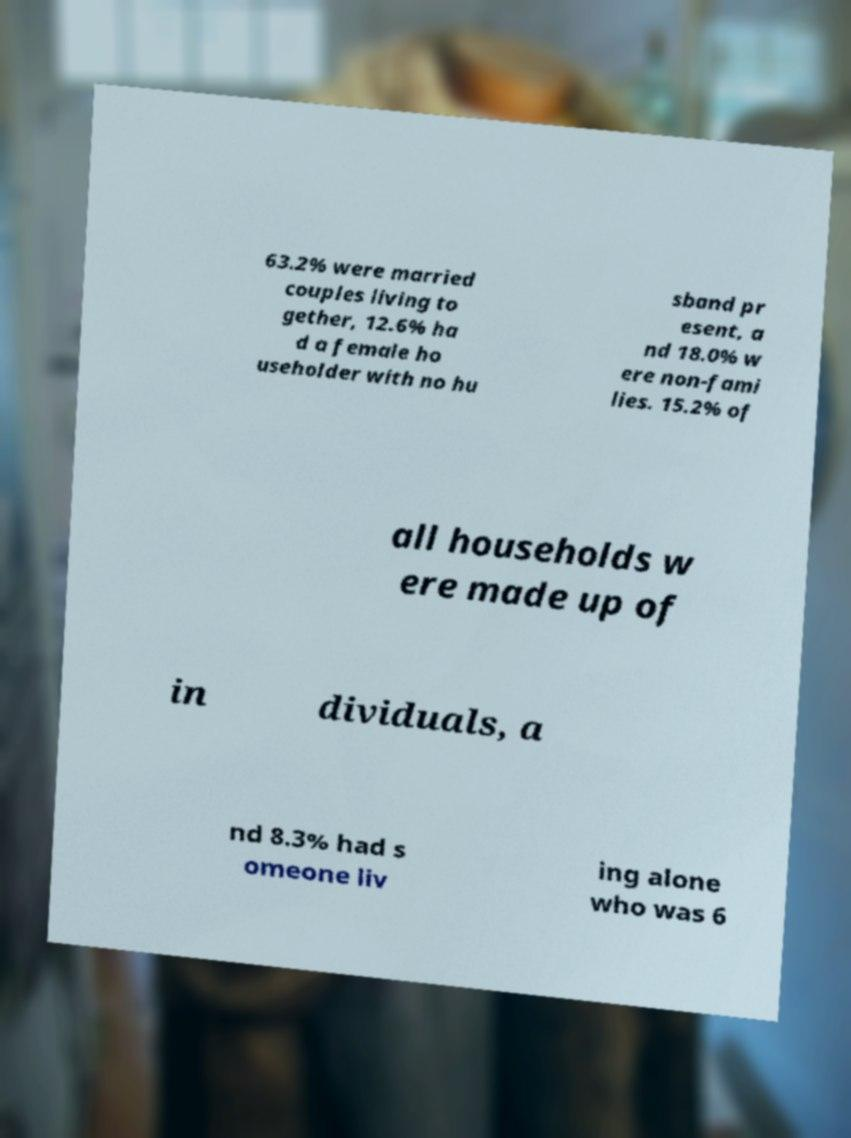What messages or text are displayed in this image? I need them in a readable, typed format. 63.2% were married couples living to gether, 12.6% ha d a female ho useholder with no hu sband pr esent, a nd 18.0% w ere non-fami lies. 15.2% of all households w ere made up of in dividuals, a nd 8.3% had s omeone liv ing alone who was 6 